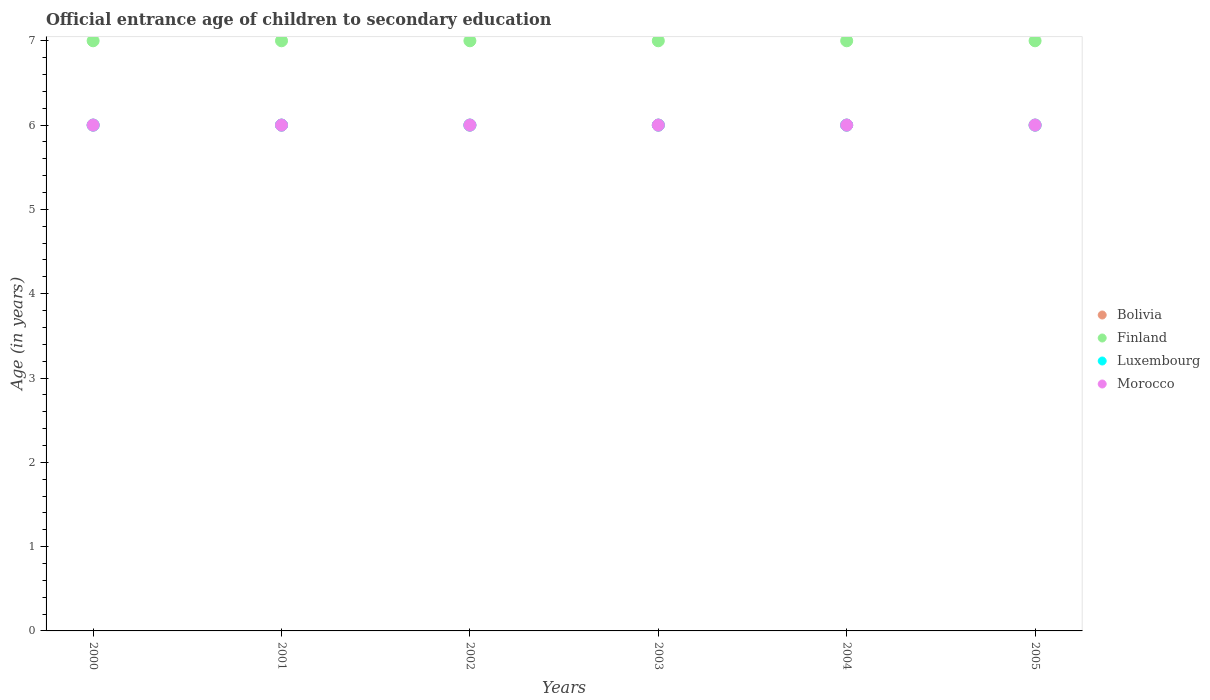Across all years, what is the maximum secondary school starting age of children in Finland?
Your answer should be compact. 7. Across all years, what is the minimum secondary school starting age of children in Finland?
Ensure brevity in your answer.  7. What is the total secondary school starting age of children in Luxembourg in the graph?
Keep it short and to the point. 36. What is the difference between the secondary school starting age of children in Morocco in 2001 and that in 2005?
Offer a terse response. 0. What is the difference between the secondary school starting age of children in Finland in 2004 and the secondary school starting age of children in Morocco in 2001?
Offer a terse response. 1. In the year 2001, what is the difference between the secondary school starting age of children in Finland and secondary school starting age of children in Bolivia?
Give a very brief answer. 1. In how many years, is the secondary school starting age of children in Morocco greater than 6.8 years?
Give a very brief answer. 0. What is the ratio of the secondary school starting age of children in Luxembourg in 2004 to that in 2005?
Your response must be concise. 1. Is the secondary school starting age of children in Morocco in 2003 less than that in 2005?
Your answer should be compact. No. What is the difference between the highest and the lowest secondary school starting age of children in Finland?
Your answer should be very brief. 0. Is the sum of the secondary school starting age of children in Luxembourg in 2003 and 2004 greater than the maximum secondary school starting age of children in Bolivia across all years?
Your answer should be compact. Yes. Does the secondary school starting age of children in Morocco monotonically increase over the years?
Your response must be concise. No. Is the secondary school starting age of children in Bolivia strictly greater than the secondary school starting age of children in Finland over the years?
Give a very brief answer. No. Is the secondary school starting age of children in Luxembourg strictly less than the secondary school starting age of children in Bolivia over the years?
Make the answer very short. No. How many dotlines are there?
Offer a terse response. 4. How many years are there in the graph?
Provide a short and direct response. 6. What is the difference between two consecutive major ticks on the Y-axis?
Your response must be concise. 1. Does the graph contain any zero values?
Ensure brevity in your answer.  No. Where does the legend appear in the graph?
Provide a succinct answer. Center right. How many legend labels are there?
Make the answer very short. 4. How are the legend labels stacked?
Keep it short and to the point. Vertical. What is the title of the graph?
Your answer should be compact. Official entrance age of children to secondary education. Does "Zambia" appear as one of the legend labels in the graph?
Your answer should be compact. No. What is the label or title of the Y-axis?
Keep it short and to the point. Age (in years). What is the Age (in years) in Bolivia in 2000?
Offer a very short reply. 6. What is the Age (in years) in Morocco in 2000?
Ensure brevity in your answer.  6. What is the Age (in years) of Finland in 2001?
Keep it short and to the point. 7. What is the Age (in years) in Morocco in 2001?
Your answer should be very brief. 6. What is the Age (in years) of Luxembourg in 2002?
Ensure brevity in your answer.  6. What is the Age (in years) in Morocco in 2002?
Your answer should be compact. 6. What is the Age (in years) of Finland in 2003?
Your response must be concise. 7. What is the Age (in years) of Morocco in 2003?
Your response must be concise. 6. What is the Age (in years) of Bolivia in 2004?
Offer a very short reply. 6. What is the Age (in years) of Finland in 2004?
Make the answer very short. 7. What is the Age (in years) in Bolivia in 2005?
Make the answer very short. 6. Across all years, what is the maximum Age (in years) of Luxembourg?
Your response must be concise. 6. Across all years, what is the maximum Age (in years) of Morocco?
Give a very brief answer. 6. Across all years, what is the minimum Age (in years) of Bolivia?
Make the answer very short. 6. Across all years, what is the minimum Age (in years) in Luxembourg?
Make the answer very short. 6. Across all years, what is the minimum Age (in years) of Morocco?
Your answer should be compact. 6. What is the total Age (in years) of Bolivia in the graph?
Provide a succinct answer. 36. What is the total Age (in years) of Finland in the graph?
Provide a short and direct response. 42. What is the total Age (in years) of Morocco in the graph?
Your response must be concise. 36. What is the difference between the Age (in years) of Bolivia in 2000 and that in 2001?
Make the answer very short. 0. What is the difference between the Age (in years) in Finland in 2000 and that in 2001?
Your answer should be very brief. 0. What is the difference between the Age (in years) of Luxembourg in 2000 and that in 2001?
Provide a succinct answer. 0. What is the difference between the Age (in years) of Bolivia in 2000 and that in 2002?
Offer a very short reply. 0. What is the difference between the Age (in years) in Finland in 2000 and that in 2002?
Your response must be concise. 0. What is the difference between the Age (in years) of Morocco in 2000 and that in 2002?
Make the answer very short. 0. What is the difference between the Age (in years) of Bolivia in 2000 and that in 2003?
Keep it short and to the point. 0. What is the difference between the Age (in years) of Morocco in 2000 and that in 2003?
Offer a terse response. 0. What is the difference between the Age (in years) in Finland in 2000 and that in 2004?
Your response must be concise. 0. What is the difference between the Age (in years) of Luxembourg in 2000 and that in 2004?
Ensure brevity in your answer.  0. What is the difference between the Age (in years) in Morocco in 2000 and that in 2004?
Make the answer very short. 0. What is the difference between the Age (in years) in Bolivia in 2000 and that in 2005?
Make the answer very short. 0. What is the difference between the Age (in years) of Finland in 2000 and that in 2005?
Offer a terse response. 0. What is the difference between the Age (in years) in Luxembourg in 2000 and that in 2005?
Ensure brevity in your answer.  0. What is the difference between the Age (in years) of Morocco in 2000 and that in 2005?
Your response must be concise. 0. What is the difference between the Age (in years) of Bolivia in 2001 and that in 2002?
Offer a terse response. 0. What is the difference between the Age (in years) of Finland in 2001 and that in 2002?
Offer a terse response. 0. What is the difference between the Age (in years) of Luxembourg in 2001 and that in 2002?
Provide a succinct answer. 0. What is the difference between the Age (in years) in Morocco in 2001 and that in 2002?
Keep it short and to the point. 0. What is the difference between the Age (in years) in Bolivia in 2001 and that in 2004?
Offer a very short reply. 0. What is the difference between the Age (in years) in Luxembourg in 2001 and that in 2004?
Give a very brief answer. 0. What is the difference between the Age (in years) in Luxembourg in 2001 and that in 2005?
Give a very brief answer. 0. What is the difference between the Age (in years) of Morocco in 2001 and that in 2005?
Offer a terse response. 0. What is the difference between the Age (in years) in Finland in 2002 and that in 2003?
Your response must be concise. 0. What is the difference between the Age (in years) of Luxembourg in 2002 and that in 2003?
Provide a succinct answer. 0. What is the difference between the Age (in years) of Morocco in 2002 and that in 2003?
Keep it short and to the point. 0. What is the difference between the Age (in years) of Bolivia in 2002 and that in 2005?
Give a very brief answer. 0. What is the difference between the Age (in years) of Finland in 2002 and that in 2005?
Your answer should be very brief. 0. What is the difference between the Age (in years) in Luxembourg in 2002 and that in 2005?
Ensure brevity in your answer.  0. What is the difference between the Age (in years) in Finland in 2003 and that in 2004?
Offer a very short reply. 0. What is the difference between the Age (in years) in Luxembourg in 2003 and that in 2004?
Your answer should be compact. 0. What is the difference between the Age (in years) in Morocco in 2003 and that in 2004?
Give a very brief answer. 0. What is the difference between the Age (in years) of Bolivia in 2003 and that in 2005?
Give a very brief answer. 0. What is the difference between the Age (in years) of Finland in 2003 and that in 2005?
Provide a succinct answer. 0. What is the difference between the Age (in years) of Morocco in 2003 and that in 2005?
Offer a terse response. 0. What is the difference between the Age (in years) in Bolivia in 2004 and that in 2005?
Your answer should be very brief. 0. What is the difference between the Age (in years) in Bolivia in 2000 and the Age (in years) in Finland in 2001?
Give a very brief answer. -1. What is the difference between the Age (in years) in Luxembourg in 2000 and the Age (in years) in Morocco in 2001?
Your answer should be very brief. 0. What is the difference between the Age (in years) of Bolivia in 2000 and the Age (in years) of Luxembourg in 2002?
Ensure brevity in your answer.  0. What is the difference between the Age (in years) of Bolivia in 2000 and the Age (in years) of Morocco in 2002?
Provide a succinct answer. 0. What is the difference between the Age (in years) of Finland in 2000 and the Age (in years) of Morocco in 2002?
Make the answer very short. 1. What is the difference between the Age (in years) in Luxembourg in 2000 and the Age (in years) in Morocco in 2002?
Offer a very short reply. 0. What is the difference between the Age (in years) in Finland in 2000 and the Age (in years) in Luxembourg in 2003?
Provide a succinct answer. 1. What is the difference between the Age (in years) of Luxembourg in 2000 and the Age (in years) of Morocco in 2003?
Your answer should be compact. 0. What is the difference between the Age (in years) in Bolivia in 2000 and the Age (in years) in Morocco in 2004?
Give a very brief answer. 0. What is the difference between the Age (in years) of Finland in 2000 and the Age (in years) of Luxembourg in 2004?
Provide a short and direct response. 1. What is the difference between the Age (in years) in Bolivia in 2000 and the Age (in years) in Finland in 2005?
Provide a short and direct response. -1. What is the difference between the Age (in years) of Bolivia in 2000 and the Age (in years) of Luxembourg in 2005?
Keep it short and to the point. 0. What is the difference between the Age (in years) of Finland in 2000 and the Age (in years) of Morocco in 2005?
Offer a terse response. 1. What is the difference between the Age (in years) of Luxembourg in 2000 and the Age (in years) of Morocco in 2005?
Ensure brevity in your answer.  0. What is the difference between the Age (in years) of Bolivia in 2001 and the Age (in years) of Finland in 2002?
Keep it short and to the point. -1. What is the difference between the Age (in years) of Finland in 2001 and the Age (in years) of Morocco in 2002?
Your answer should be compact. 1. What is the difference between the Age (in years) in Bolivia in 2001 and the Age (in years) in Finland in 2003?
Your response must be concise. -1. What is the difference between the Age (in years) in Bolivia in 2001 and the Age (in years) in Morocco in 2003?
Offer a very short reply. 0. What is the difference between the Age (in years) in Finland in 2001 and the Age (in years) in Luxembourg in 2003?
Your answer should be compact. 1. What is the difference between the Age (in years) in Finland in 2001 and the Age (in years) in Morocco in 2003?
Provide a succinct answer. 1. What is the difference between the Age (in years) of Bolivia in 2001 and the Age (in years) of Finland in 2004?
Your answer should be compact. -1. What is the difference between the Age (in years) of Luxembourg in 2001 and the Age (in years) of Morocco in 2004?
Offer a terse response. 0. What is the difference between the Age (in years) in Bolivia in 2001 and the Age (in years) in Finland in 2005?
Ensure brevity in your answer.  -1. What is the difference between the Age (in years) in Bolivia in 2001 and the Age (in years) in Luxembourg in 2005?
Your answer should be very brief. 0. What is the difference between the Age (in years) of Bolivia in 2001 and the Age (in years) of Morocco in 2005?
Your answer should be very brief. 0. What is the difference between the Age (in years) in Luxembourg in 2001 and the Age (in years) in Morocco in 2005?
Make the answer very short. 0. What is the difference between the Age (in years) of Bolivia in 2002 and the Age (in years) of Finland in 2003?
Provide a succinct answer. -1. What is the difference between the Age (in years) in Finland in 2002 and the Age (in years) in Luxembourg in 2003?
Your answer should be very brief. 1. What is the difference between the Age (in years) of Bolivia in 2002 and the Age (in years) of Finland in 2004?
Your answer should be compact. -1. What is the difference between the Age (in years) in Bolivia in 2002 and the Age (in years) in Morocco in 2004?
Make the answer very short. 0. What is the difference between the Age (in years) of Finland in 2002 and the Age (in years) of Morocco in 2004?
Give a very brief answer. 1. What is the difference between the Age (in years) of Bolivia in 2002 and the Age (in years) of Finland in 2005?
Your answer should be compact. -1. What is the difference between the Age (in years) of Bolivia in 2002 and the Age (in years) of Luxembourg in 2005?
Offer a terse response. 0. What is the difference between the Age (in years) in Finland in 2002 and the Age (in years) in Luxembourg in 2005?
Your response must be concise. 1. What is the difference between the Age (in years) in Luxembourg in 2002 and the Age (in years) in Morocco in 2005?
Your answer should be compact. 0. What is the difference between the Age (in years) in Bolivia in 2003 and the Age (in years) in Finland in 2004?
Your answer should be compact. -1. What is the difference between the Age (in years) of Bolivia in 2003 and the Age (in years) of Luxembourg in 2004?
Your answer should be very brief. 0. What is the difference between the Age (in years) of Bolivia in 2003 and the Age (in years) of Morocco in 2004?
Keep it short and to the point. 0. What is the difference between the Age (in years) in Bolivia in 2003 and the Age (in years) in Finland in 2005?
Your answer should be compact. -1. What is the difference between the Age (in years) of Finland in 2003 and the Age (in years) of Luxembourg in 2005?
Give a very brief answer. 1. What is the difference between the Age (in years) in Bolivia in 2004 and the Age (in years) in Luxembourg in 2005?
Ensure brevity in your answer.  0. What is the difference between the Age (in years) of Bolivia in 2004 and the Age (in years) of Morocco in 2005?
Provide a short and direct response. 0. What is the difference between the Age (in years) in Finland in 2004 and the Age (in years) in Luxembourg in 2005?
Your answer should be compact. 1. What is the difference between the Age (in years) of Finland in 2004 and the Age (in years) of Morocco in 2005?
Keep it short and to the point. 1. What is the difference between the Age (in years) of Luxembourg in 2004 and the Age (in years) of Morocco in 2005?
Give a very brief answer. 0. What is the average Age (in years) in Bolivia per year?
Provide a short and direct response. 6. In the year 2000, what is the difference between the Age (in years) of Bolivia and Age (in years) of Finland?
Give a very brief answer. -1. In the year 2000, what is the difference between the Age (in years) of Finland and Age (in years) of Luxembourg?
Your answer should be very brief. 1. In the year 2000, what is the difference between the Age (in years) of Finland and Age (in years) of Morocco?
Provide a short and direct response. 1. In the year 2000, what is the difference between the Age (in years) of Luxembourg and Age (in years) of Morocco?
Your response must be concise. 0. In the year 2001, what is the difference between the Age (in years) of Bolivia and Age (in years) of Finland?
Provide a succinct answer. -1. In the year 2001, what is the difference between the Age (in years) in Bolivia and Age (in years) in Morocco?
Give a very brief answer. 0. In the year 2001, what is the difference between the Age (in years) of Finland and Age (in years) of Morocco?
Offer a very short reply. 1. In the year 2002, what is the difference between the Age (in years) in Bolivia and Age (in years) in Finland?
Ensure brevity in your answer.  -1. In the year 2002, what is the difference between the Age (in years) of Finland and Age (in years) of Luxembourg?
Your answer should be very brief. 1. In the year 2003, what is the difference between the Age (in years) of Bolivia and Age (in years) of Finland?
Give a very brief answer. -1. In the year 2003, what is the difference between the Age (in years) in Bolivia and Age (in years) in Luxembourg?
Ensure brevity in your answer.  0. In the year 2003, what is the difference between the Age (in years) of Finland and Age (in years) of Luxembourg?
Keep it short and to the point. 1. In the year 2003, what is the difference between the Age (in years) in Luxembourg and Age (in years) in Morocco?
Your answer should be compact. 0. In the year 2004, what is the difference between the Age (in years) of Bolivia and Age (in years) of Morocco?
Offer a very short reply. 0. In the year 2005, what is the difference between the Age (in years) of Finland and Age (in years) of Luxembourg?
Make the answer very short. 1. In the year 2005, what is the difference between the Age (in years) in Luxembourg and Age (in years) in Morocco?
Provide a succinct answer. 0. What is the ratio of the Age (in years) in Bolivia in 2000 to that in 2001?
Make the answer very short. 1. What is the ratio of the Age (in years) in Luxembourg in 2000 to that in 2001?
Make the answer very short. 1. What is the ratio of the Age (in years) of Morocco in 2000 to that in 2001?
Ensure brevity in your answer.  1. What is the ratio of the Age (in years) in Bolivia in 2000 to that in 2002?
Offer a very short reply. 1. What is the ratio of the Age (in years) of Finland in 2000 to that in 2002?
Your answer should be compact. 1. What is the ratio of the Age (in years) of Morocco in 2000 to that in 2002?
Your response must be concise. 1. What is the ratio of the Age (in years) in Finland in 2000 to that in 2003?
Provide a succinct answer. 1. What is the ratio of the Age (in years) in Luxembourg in 2000 to that in 2003?
Provide a succinct answer. 1. What is the ratio of the Age (in years) in Finland in 2000 to that in 2004?
Your answer should be very brief. 1. What is the ratio of the Age (in years) in Luxembourg in 2000 to that in 2004?
Make the answer very short. 1. What is the ratio of the Age (in years) in Finland in 2000 to that in 2005?
Your answer should be compact. 1. What is the ratio of the Age (in years) of Luxembourg in 2000 to that in 2005?
Offer a terse response. 1. What is the ratio of the Age (in years) of Morocco in 2000 to that in 2005?
Make the answer very short. 1. What is the ratio of the Age (in years) of Bolivia in 2001 to that in 2002?
Provide a succinct answer. 1. What is the ratio of the Age (in years) in Morocco in 2001 to that in 2002?
Provide a succinct answer. 1. What is the ratio of the Age (in years) of Morocco in 2001 to that in 2003?
Provide a short and direct response. 1. What is the ratio of the Age (in years) of Finland in 2001 to that in 2004?
Provide a short and direct response. 1. What is the ratio of the Age (in years) of Morocco in 2001 to that in 2004?
Keep it short and to the point. 1. What is the ratio of the Age (in years) of Morocco in 2001 to that in 2005?
Keep it short and to the point. 1. What is the ratio of the Age (in years) in Bolivia in 2002 to that in 2003?
Provide a succinct answer. 1. What is the ratio of the Age (in years) in Finland in 2002 to that in 2003?
Offer a terse response. 1. What is the ratio of the Age (in years) in Luxembourg in 2002 to that in 2005?
Give a very brief answer. 1. What is the ratio of the Age (in years) of Bolivia in 2003 to that in 2004?
Ensure brevity in your answer.  1. What is the ratio of the Age (in years) in Finland in 2003 to that in 2004?
Offer a very short reply. 1. What is the ratio of the Age (in years) in Morocco in 2003 to that in 2004?
Your answer should be compact. 1. What is the ratio of the Age (in years) in Morocco in 2003 to that in 2005?
Your response must be concise. 1. What is the difference between the highest and the second highest Age (in years) in Morocco?
Make the answer very short. 0. What is the difference between the highest and the lowest Age (in years) in Finland?
Your answer should be very brief. 0. What is the difference between the highest and the lowest Age (in years) of Morocco?
Your answer should be very brief. 0. 